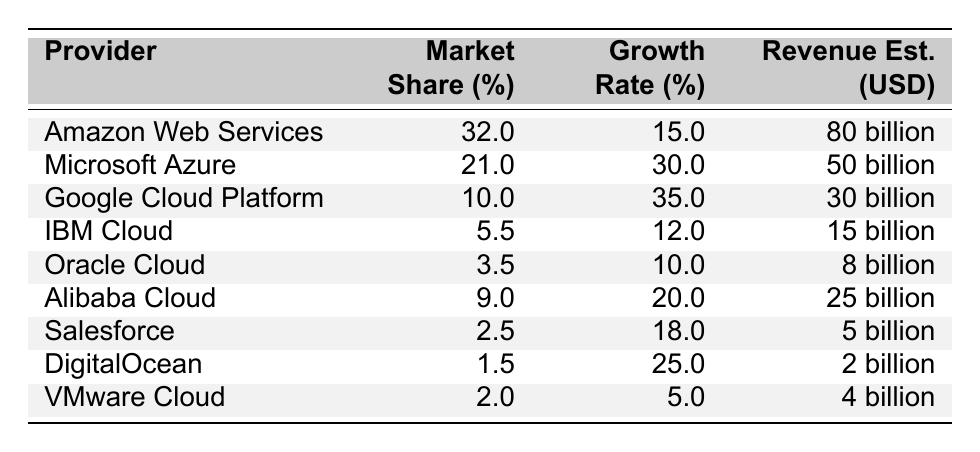What is the market share percentage of Amazon Web Services? According to the table, Amazon Web Services (AWS) has a market share percentage of 32.0%.
Answer: 32.0% Which cloud provider has the highest annual growth rate? The table indicates that Google Cloud Platform has the highest annual growth rate at 35.0%.
Answer: Google Cloud Platform What is the estimated revenue for Oracle Cloud? From the table, Oracle Cloud's estimated revenue is reported as 8 billion USD.
Answer: 8 billion USD What is the combined market share of the top three cloud providers? The top three cloud providers are AWS (32.0%), Microsoft Azure (21.0%), and Google Cloud Platform (10.0). Adding these together: 32.0 + 21.0 + 10.0 = 63.0%.
Answer: 63.0% Is Microsoft's Azure growth rate greater than AWS's growth rate? Microsoft Azure has a growth rate of 30.0%, while AWS has a growth rate of 15.0%. Therefore, Microsoft's Azure growth rate is indeed greater than AWS's.
Answer: Yes What is the difference in market share percentage between Alibaba Cloud and Oracle Cloud? Alibaba Cloud has a market share of 9.0%, and Oracle Cloud has a market share of 3.5%. The difference is calculated as 9.0 - 3.5 = 5.5%.
Answer: 5.5% Which cloud provider has a revenue estimate of 25 billion USD? The table shows that Alibaba Cloud has a revenue estimate of 25 billion USD.
Answer: Alibaba Cloud What is the average growth rate of the cloud providers listed in the table? To find the average growth rate, add all the growth rates: 15.0 + 30.0 + 35.0 + 12.0 + 10.0 + 20.0 + 18.0 + 25.0 + 5.0 =  145.0%. Then, divide this by the number of providers (9): 145.0% / 9 ≈ 16.1%.
Answer: 16.1% How much greater is the market share of AWS compared to DigitalOcean? AWS has a market share of 32.0%, and DigitalOcean has a market share of 1.5%. The difference is calculated as 32.0 - 1.5 = 30.5%.
Answer: 30.5% Which provider has the least market share and what is that percentage? According to the table, DigitalOcean has the least market share, which is 1.5%.
Answer: 1.5% 